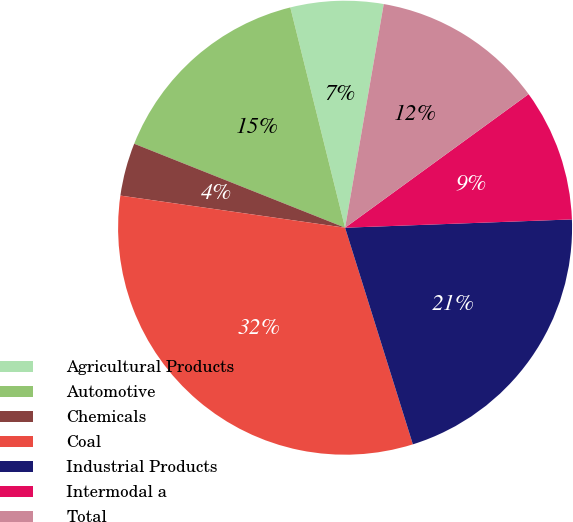Convert chart. <chart><loc_0><loc_0><loc_500><loc_500><pie_chart><fcel>Agricultural Products<fcel>Automotive<fcel>Chemicals<fcel>Coal<fcel>Industrial Products<fcel>Intermodal a<fcel>Total<nl><fcel>6.6%<fcel>15.09%<fcel>3.77%<fcel>32.08%<fcel>20.75%<fcel>9.43%<fcel>12.26%<nl></chart> 